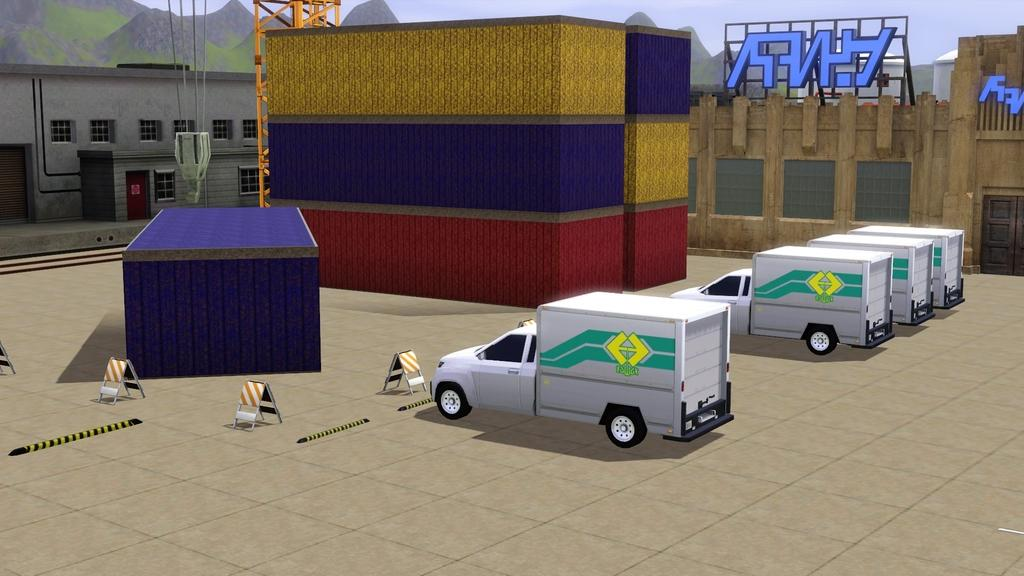What type of images are present in the picture? The picture contains cartoon images of vehicles, containers, buildings, hills, and hoardings. Can you describe the setting of the cartoon images? The cartoon images depict a scene with vehicles, containers, buildings, hills, and hoardings. Are there any specific features of the cartoon images that stand out? The cartoon images are of vehicles, containers, buildings, hills, and hoardings, which suggests a city or town setting. What type of quince is being delivered in the parcel in the image? There is no parcel or quince present in the image; it contains cartoon images of vehicles, containers, buildings, hills, and hoardings. What type of destruction is depicted in the image? There is no destruction depicted in the image; it contains cartoon images of vehicles, containers, buildings, hills, and hoardings in a city or town setting. 